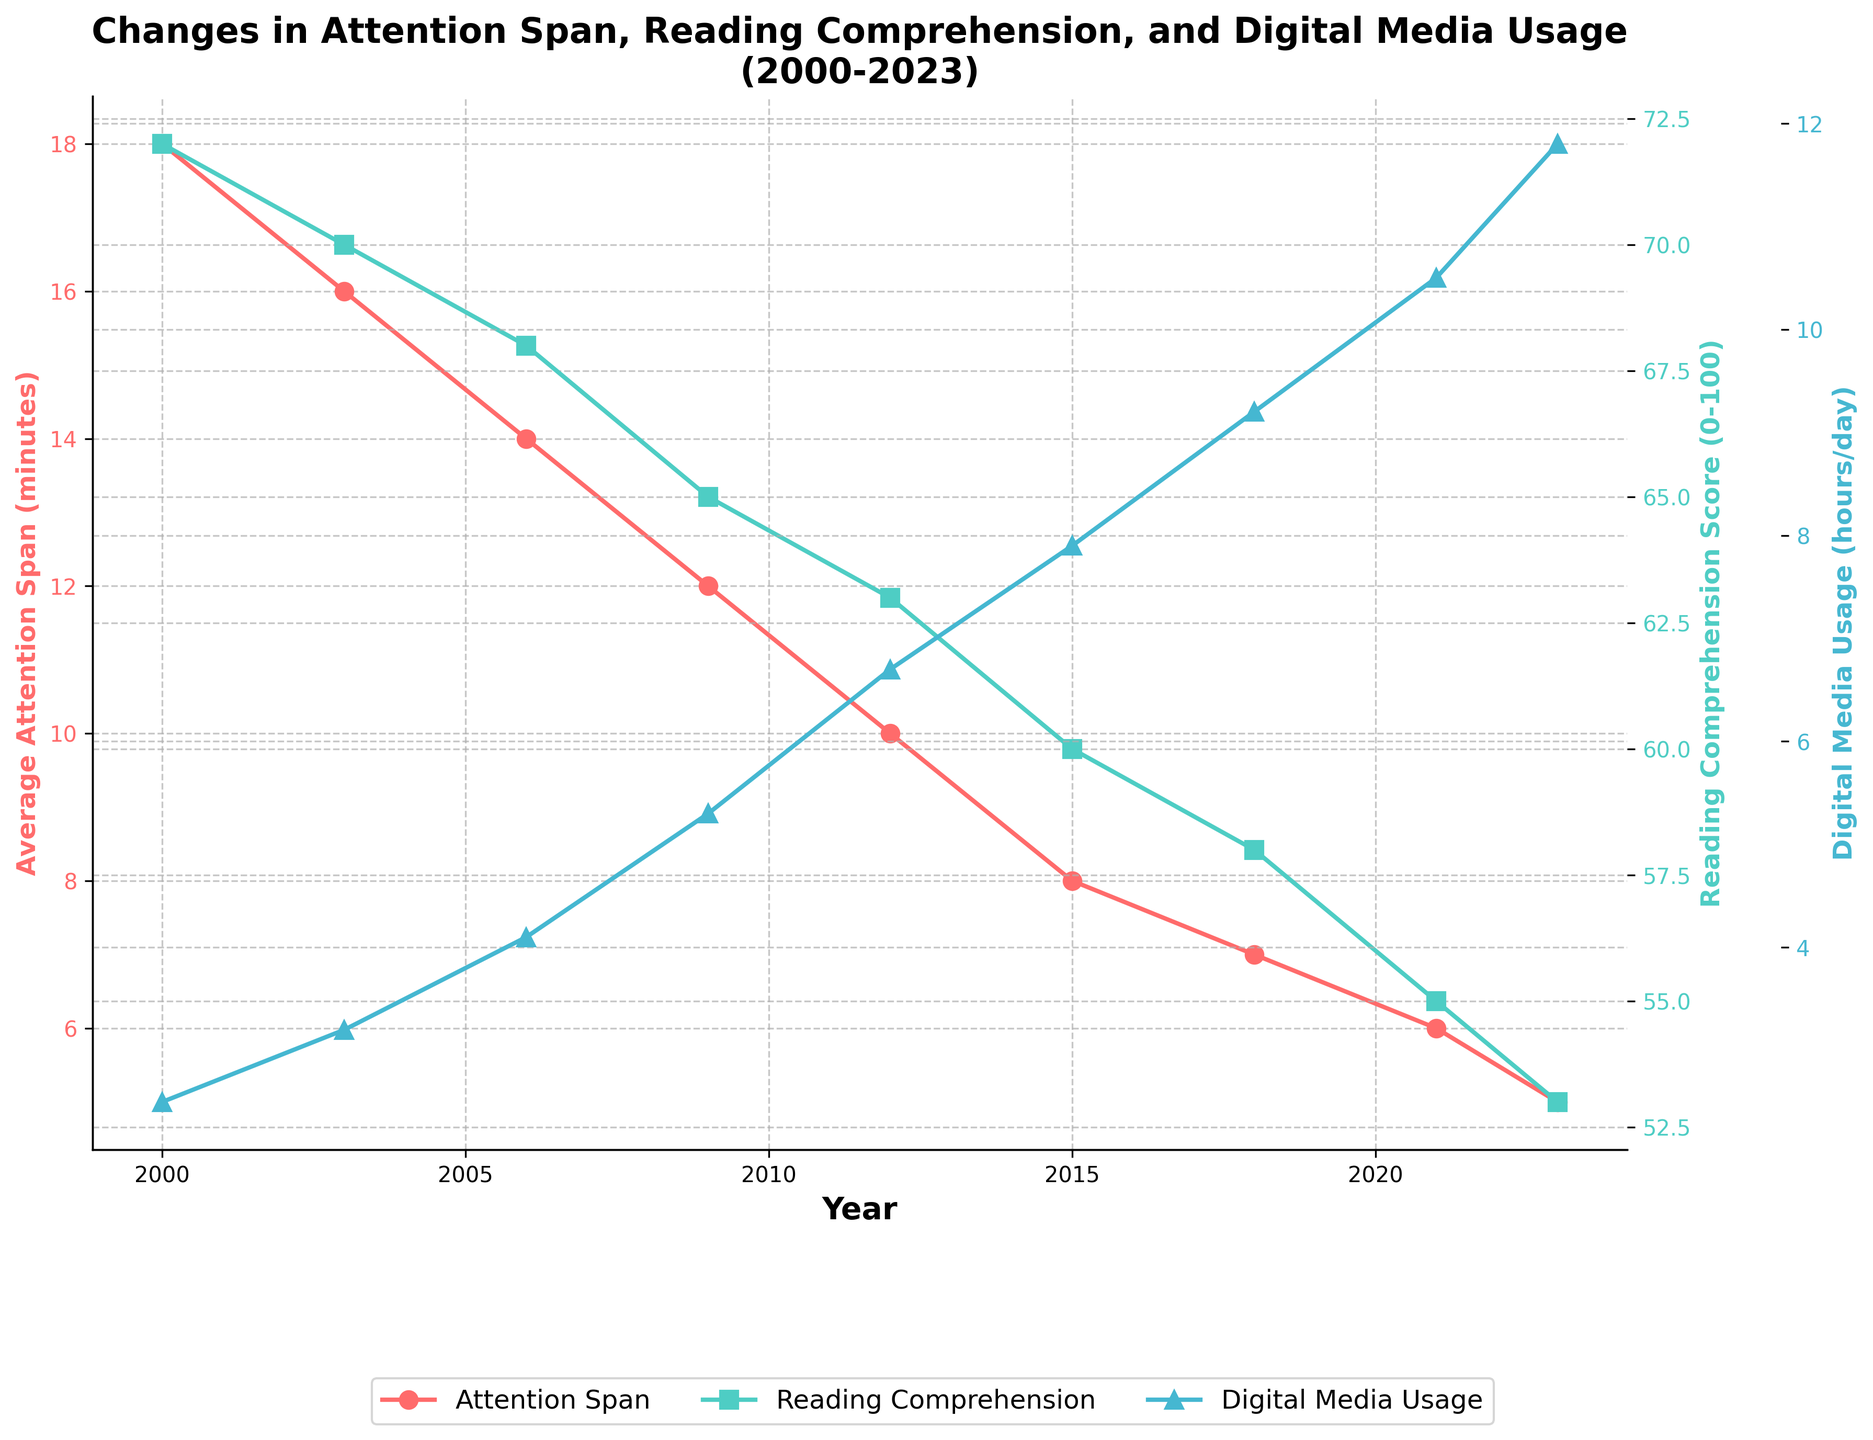What is the trend in average attention span from 2000 to 2023? The figure shows a decreasing trend in average attention span over the years. Starting at 18 minutes in 2000, it drops steadily to 5 minutes by 2023.
Answer: Decreasing trend How has the reading comprehension score changed from 2000 to 2023? The reading comprehension score has shown a decreasing trend from 2000 to 2023. It starts at 72 in 2000 and declines to 53 by 2023.
Answer: Decreasing trend What is the relationship between digital media usage and reading comprehension scores in 2023? Digital media usage is 11.8 hours per day and reading comprehension score is 53 in 2023. Referring to the figure, a higher digital media usage corresponds to lower reading comprehension scores.
Answer: Higher media usage, lower reading comprehension What year shows the most significant drop in average attention span? Comparing the yearly changes, from 2000 to 2003, there's a drop of 2 minutes. Other three-year periods show smaller drops, making 2000-2003 the most significant drop.
Answer: 2000 to 2003 Compare the reading comprehension scores and digital media usage in 2006 and 2021. In 2006, the reading comprehension score is 68 and digital media usage is 4.1 hours/day. In 2021, the scores drop to 55 while usage rises to 10.5 hours/day. This shows reading comprehension declines as digital media usage increases over the years.
Answer: 68 vs 55; 4.1 vs 10.5 Which year had the lowest average attention span and what was it? The lowest average attention span is observed in 2023, where it is 5 minutes.
Answer: 2023, 5 minutes What has been the overall percentage decrease in the reading comprehension score from 2000 to 2023? The reading comprehension score dropped from 72 in 2000 to 53 in 2023. The percentage decrease is calculated as [(72-53)/72]*100 = 26.39%.
Answer: 26.39% Describe the trends in digital media usage and its potential impact on the other two metrics. The figure shows a steady increase in digital media usage from 2.5 to 11.8 hours/day. Correspondingly, both average attention spans and reading comprehension scores exhibit decreasing trends. This suggests an inverse relationship impacting attention and comprehension negatively.
Answer: Increase in media usage, decrease in attention and comprehension What are the visual attributes (colors) representing each metric in the figure? Average attention span is represented in red, reading comprehension score in green, and digital media usage in blue.
Answer: Red, green, blue 